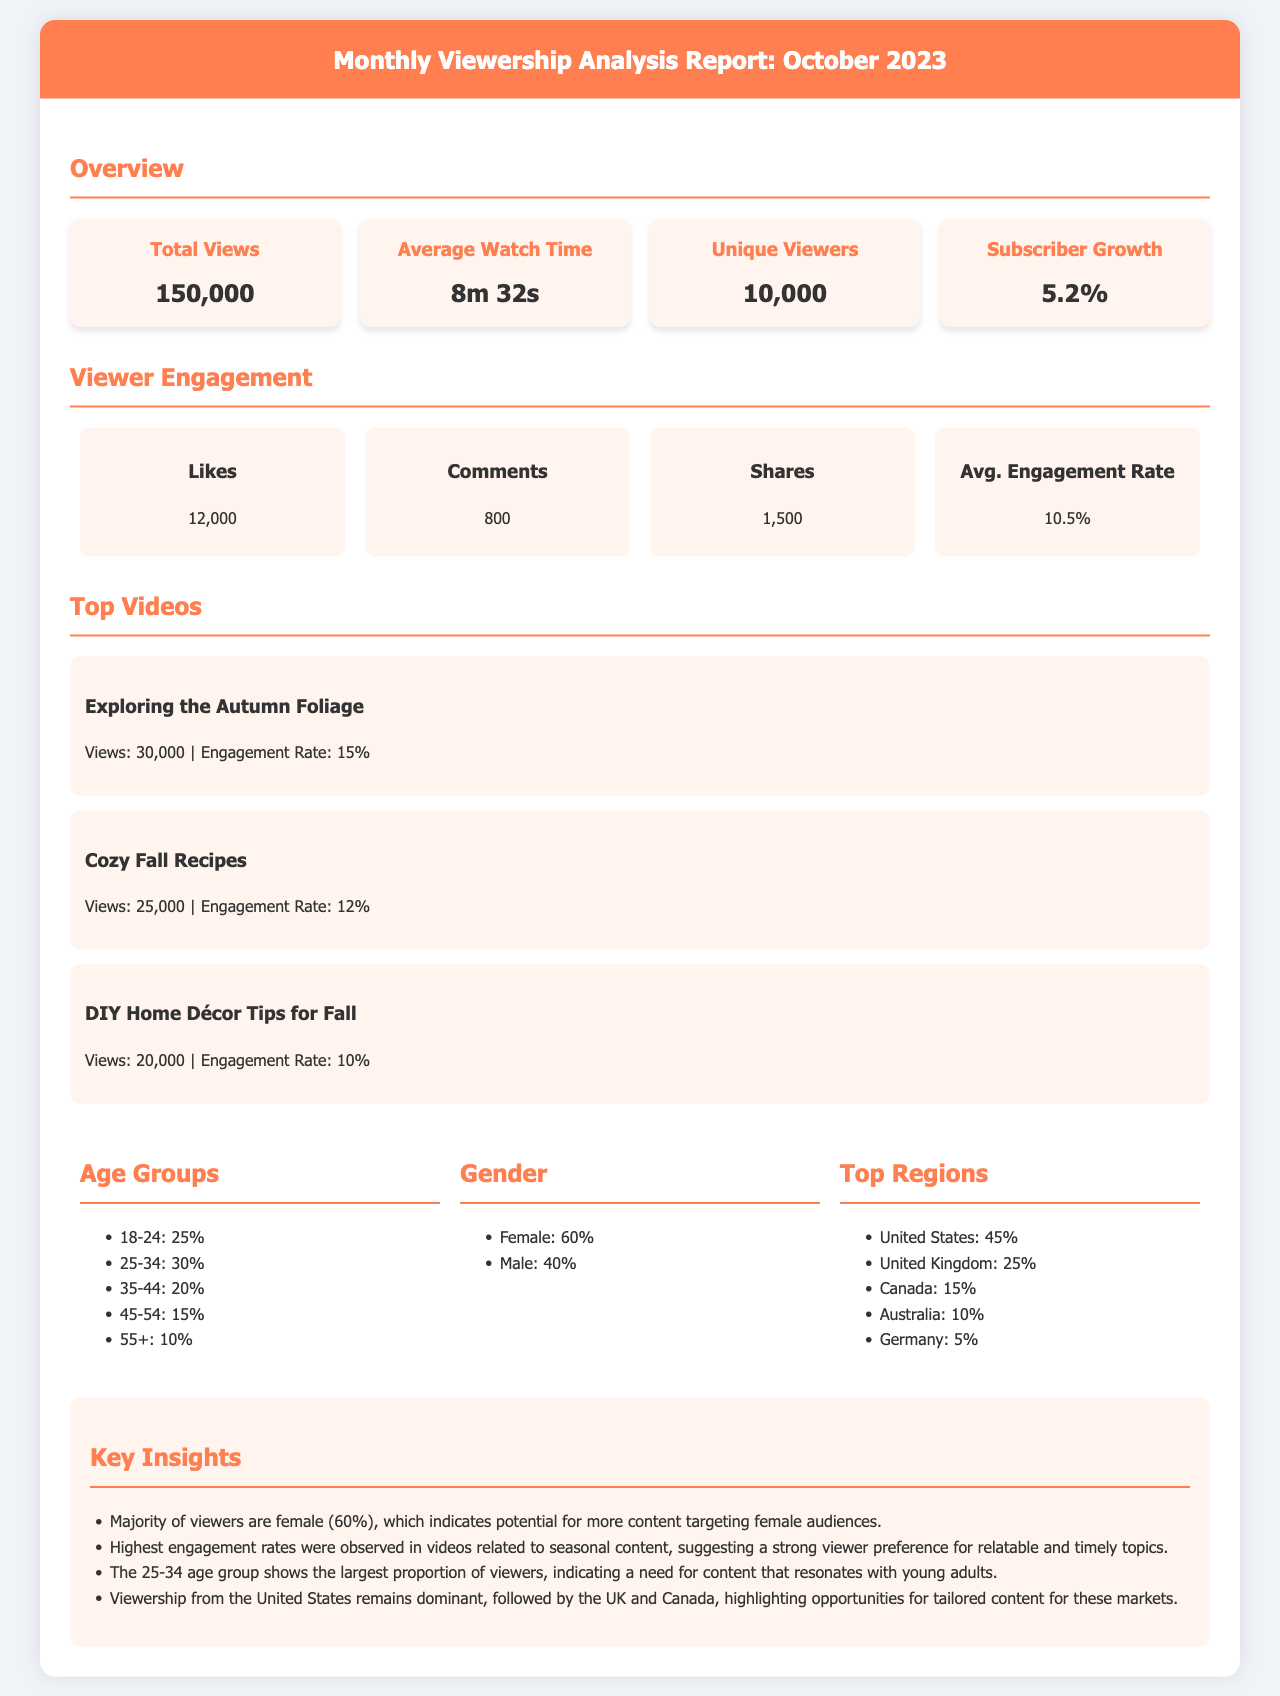What is the total number of views? The total number of views listed in the overview section of the report is 150,000.
Answer: 150,000 What is the average watch time? The average watch time mentioned in the report is 8 minutes and 32 seconds.
Answer: 8m 32s What percentage of viewers are aged 25-34? The age group 25-34 makes up 30% of the total viewers according to the demographics section.
Answer: 30% Which video had the highest engagement rate? The video "Exploring the Autumn Foliage" had the highest engagement rate at 15%.
Answer: Exploring the Autumn Foliage How many likes did the videos receive in total? The total number of likes mentioned in the engagement section is 12,000.
Answer: 12,000 What is the subscriber growth percentage? The subscriber growth percentage stated in the report is 5.2%.
Answer: 5.2% What is the primary gender demographic of the viewers? The report indicates that the majority of viewers are female, comprising 60% of the audience.
Answer: Female Where do most viewers come from? Viewership is predominantly from the United States, which accounts for 45% of the total audience.
Answer: United States What topic shows strong viewer preference based on engagement rates? Videos related to seasonal content, highlighted in the key insights, show a strong viewer preference.
Answer: Seasonal content 